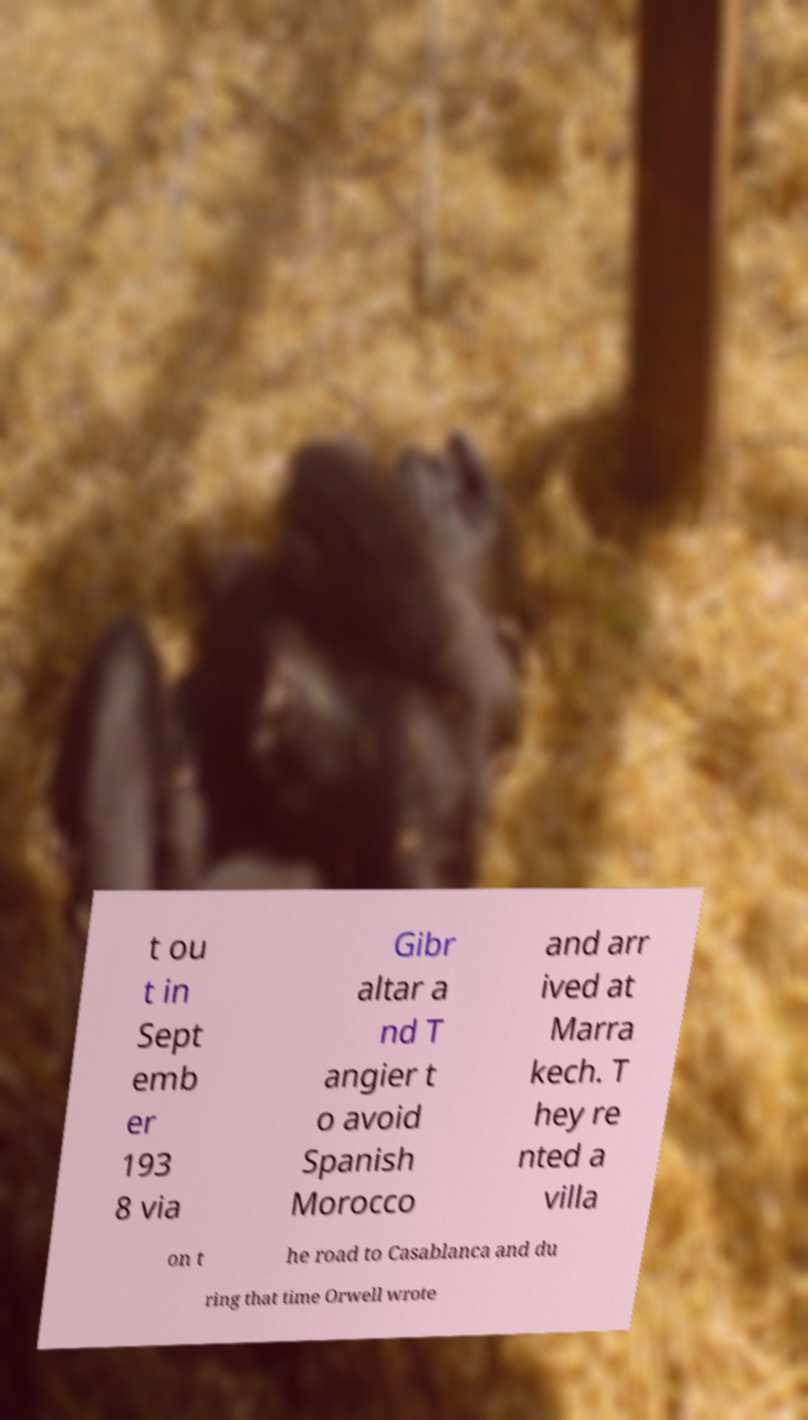Can you read and provide the text displayed in the image?This photo seems to have some interesting text. Can you extract and type it out for me? t ou t in Sept emb er 193 8 via Gibr altar a nd T angier t o avoid Spanish Morocco and arr ived at Marra kech. T hey re nted a villa on t he road to Casablanca and du ring that time Orwell wrote 